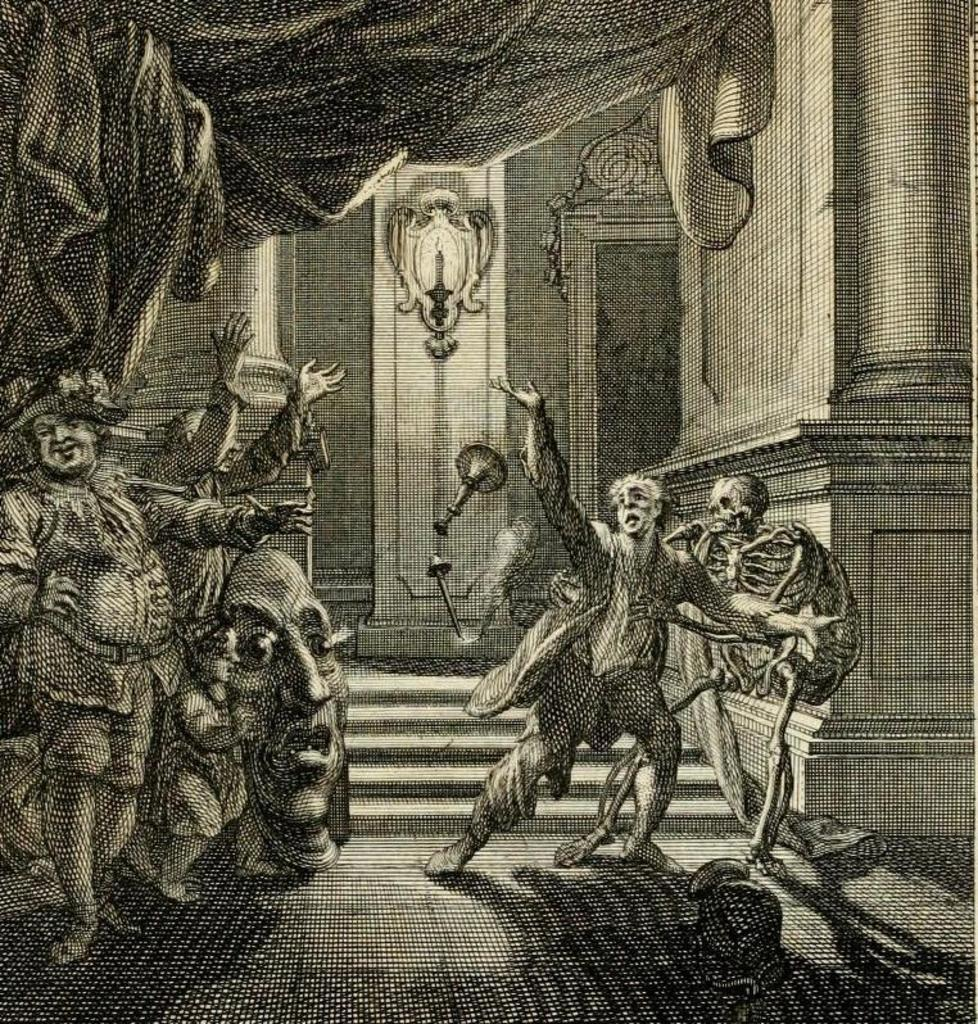What is the main subject of the sketch in the image? The main subject of the sketch in the image is people. What architectural elements are included in the sketch? The sketch includes a floor, a pillar, a wall, a curtain, and stairs. Are there any unspecified objects in the sketch? Yes, there are some unspecified objects in the sketch. What type of meat is being cooked on the stove in the image? There is no stove or meat present in the image; it contains a sketch of people and architectural elements. 